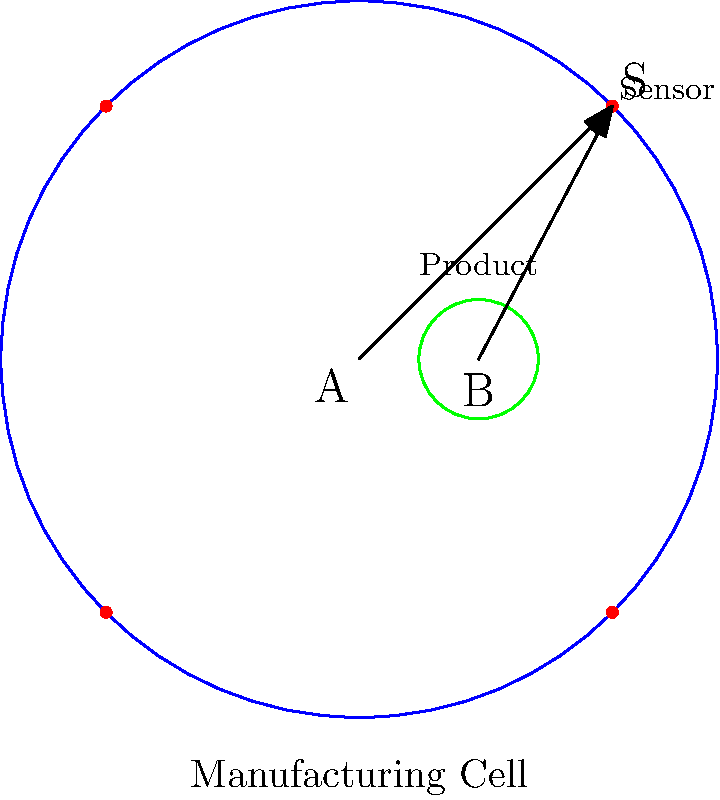En una celda de manufactura circular, se necesita optimizar la colocación de sensores para detectar un producto. El centro de la celda está en el origen (0,0), y el producto está ubicado en (1,0). Un sensor está en la posición (2.12, 2.12). Utilizando el producto punto, determina si el ángulo entre el vector del centro de la celda al sensor y el vector del producto al sensor es mayor o menor que 45°. ¿Qué implica esto para la efectividad del sensor? Para resolver este problema, seguiremos estos pasos:

1) Definimos los vectores:
   Vector centro-sensor: $\vec{AS} = (2.12, 2.12) - (0, 0) = (2.12, 2.12)$
   Vector producto-sensor: $\vec{BS} = (2.12, 2.12) - (1, 0) = (1.12, 2.12)$

2) Calculamos el producto punto de estos vectores:
   $\vec{AS} \cdot \vec{BS} = (2.12)(1.12) + (2.12)(2.12) = 2.3744 + 4.4944 = 6.8688$

3) Calculamos las magnitudes de los vectores:
   $|\vec{AS}| = \sqrt{2.12^2 + 2.12^2} = 3$
   $|\vec{BS}| = \sqrt{1.12^2 + 2.12^2} = 2.4$

4) Usamos la fórmula del producto punto: $\vec{A} \cdot \vec{B} = |\vec{A}||\vec{B}|\cos\theta$
   $6.8688 = (3)(2.4)\cos\theta$

5) Despejamos $\cos\theta$:
   $\cos\theta = \frac{6.8688}{7.2} = 0.954$

6) El $\cos(45°) = \frac{\sqrt{2}}{2} \approx 0.707$

7) Como $0.954 > 0.707$, el ángulo es menor que 45°.

8) Un ángulo menor que 45° implica que el sensor está bien posicionado para detectar el producto, ya que está más alineado con la línea de visión directa entre el centro de la celda y el producto.
Answer: Ángulo < 45°; sensor efectivo 